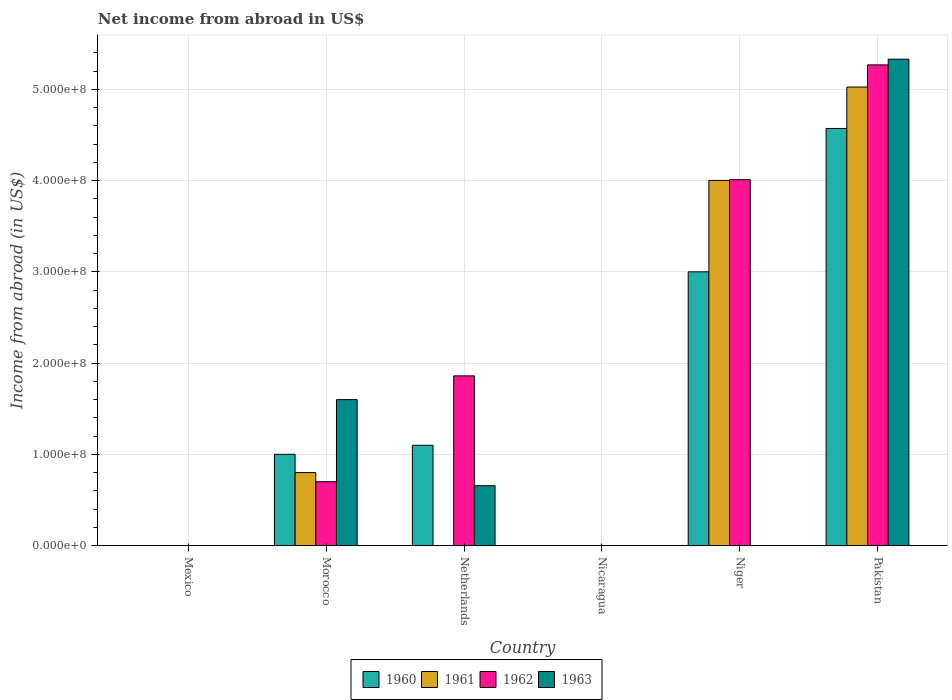How many different coloured bars are there?
Your answer should be very brief. 4. How many bars are there on the 1st tick from the right?
Your answer should be compact. 4. What is the label of the 5th group of bars from the left?
Offer a terse response. Niger. What is the net income from abroad in 1961 in Netherlands?
Offer a terse response. 0. Across all countries, what is the maximum net income from abroad in 1961?
Keep it short and to the point. 5.03e+08. Across all countries, what is the minimum net income from abroad in 1960?
Ensure brevity in your answer.  0. In which country was the net income from abroad in 1961 maximum?
Provide a short and direct response. Pakistan. What is the total net income from abroad in 1960 in the graph?
Ensure brevity in your answer.  9.67e+08. What is the difference between the net income from abroad in 1961 in Morocco and that in Niger?
Offer a terse response. -3.20e+08. What is the difference between the net income from abroad in 1960 in Pakistan and the net income from abroad in 1961 in Niger?
Offer a terse response. 5.70e+07. What is the average net income from abroad in 1961 per country?
Keep it short and to the point. 1.64e+08. What is the difference between the net income from abroad of/in 1961 and net income from abroad of/in 1960 in Morocco?
Give a very brief answer. -2.00e+07. In how many countries, is the net income from abroad in 1963 greater than 420000000 US$?
Ensure brevity in your answer.  1. What is the difference between the highest and the second highest net income from abroad in 1963?
Your answer should be very brief. 9.44e+07. What is the difference between the highest and the lowest net income from abroad in 1961?
Ensure brevity in your answer.  5.03e+08. Is it the case that in every country, the sum of the net income from abroad in 1960 and net income from abroad in 1963 is greater than the sum of net income from abroad in 1962 and net income from abroad in 1961?
Provide a succinct answer. No. Are all the bars in the graph horizontal?
Your answer should be compact. No. How many countries are there in the graph?
Your answer should be compact. 6. What is the difference between two consecutive major ticks on the Y-axis?
Make the answer very short. 1.00e+08. Are the values on the major ticks of Y-axis written in scientific E-notation?
Your answer should be compact. Yes. How many legend labels are there?
Your answer should be very brief. 4. What is the title of the graph?
Offer a terse response. Net income from abroad in US$. What is the label or title of the Y-axis?
Make the answer very short. Income from abroad (in US$). What is the Income from abroad (in US$) of 1961 in Mexico?
Provide a short and direct response. 0. What is the Income from abroad (in US$) of 1962 in Mexico?
Ensure brevity in your answer.  0. What is the Income from abroad (in US$) in 1963 in Mexico?
Offer a terse response. 0. What is the Income from abroad (in US$) of 1960 in Morocco?
Your answer should be very brief. 1.00e+08. What is the Income from abroad (in US$) in 1961 in Morocco?
Provide a succinct answer. 8.00e+07. What is the Income from abroad (in US$) of 1962 in Morocco?
Ensure brevity in your answer.  7.00e+07. What is the Income from abroad (in US$) in 1963 in Morocco?
Offer a very short reply. 1.60e+08. What is the Income from abroad (in US$) of 1960 in Netherlands?
Make the answer very short. 1.10e+08. What is the Income from abroad (in US$) of 1962 in Netherlands?
Provide a short and direct response. 1.86e+08. What is the Income from abroad (in US$) in 1963 in Netherlands?
Offer a very short reply. 6.56e+07. What is the Income from abroad (in US$) of 1960 in Nicaragua?
Ensure brevity in your answer.  0. What is the Income from abroad (in US$) in 1961 in Nicaragua?
Offer a terse response. 0. What is the Income from abroad (in US$) of 1962 in Nicaragua?
Your response must be concise. 0. What is the Income from abroad (in US$) of 1963 in Nicaragua?
Give a very brief answer. 0. What is the Income from abroad (in US$) of 1960 in Niger?
Ensure brevity in your answer.  3.00e+08. What is the Income from abroad (in US$) in 1961 in Niger?
Give a very brief answer. 4.00e+08. What is the Income from abroad (in US$) of 1962 in Niger?
Keep it short and to the point. 4.01e+08. What is the Income from abroad (in US$) in 1960 in Pakistan?
Provide a short and direct response. 4.57e+08. What is the Income from abroad (in US$) of 1961 in Pakistan?
Keep it short and to the point. 5.03e+08. What is the Income from abroad (in US$) in 1962 in Pakistan?
Provide a short and direct response. 5.27e+08. What is the Income from abroad (in US$) in 1963 in Pakistan?
Provide a succinct answer. 5.33e+08. Across all countries, what is the maximum Income from abroad (in US$) of 1960?
Provide a succinct answer. 4.57e+08. Across all countries, what is the maximum Income from abroad (in US$) in 1961?
Your answer should be very brief. 5.03e+08. Across all countries, what is the maximum Income from abroad (in US$) in 1962?
Keep it short and to the point. 5.27e+08. Across all countries, what is the maximum Income from abroad (in US$) in 1963?
Make the answer very short. 5.33e+08. Across all countries, what is the minimum Income from abroad (in US$) of 1960?
Offer a very short reply. 0. Across all countries, what is the minimum Income from abroad (in US$) of 1962?
Offer a very short reply. 0. What is the total Income from abroad (in US$) of 1960 in the graph?
Keep it short and to the point. 9.67e+08. What is the total Income from abroad (in US$) of 1961 in the graph?
Make the answer very short. 9.83e+08. What is the total Income from abroad (in US$) of 1962 in the graph?
Provide a short and direct response. 1.18e+09. What is the total Income from abroad (in US$) in 1963 in the graph?
Offer a very short reply. 7.59e+08. What is the difference between the Income from abroad (in US$) in 1960 in Morocco and that in Netherlands?
Your response must be concise. -9.95e+06. What is the difference between the Income from abroad (in US$) in 1962 in Morocco and that in Netherlands?
Keep it short and to the point. -1.16e+08. What is the difference between the Income from abroad (in US$) in 1963 in Morocco and that in Netherlands?
Give a very brief answer. 9.44e+07. What is the difference between the Income from abroad (in US$) of 1960 in Morocco and that in Niger?
Offer a terse response. -2.00e+08. What is the difference between the Income from abroad (in US$) of 1961 in Morocco and that in Niger?
Provide a succinct answer. -3.20e+08. What is the difference between the Income from abroad (in US$) of 1962 in Morocco and that in Niger?
Give a very brief answer. -3.31e+08. What is the difference between the Income from abroad (in US$) of 1960 in Morocco and that in Pakistan?
Provide a short and direct response. -3.57e+08. What is the difference between the Income from abroad (in US$) in 1961 in Morocco and that in Pakistan?
Give a very brief answer. -4.23e+08. What is the difference between the Income from abroad (in US$) in 1962 in Morocco and that in Pakistan?
Offer a terse response. -4.57e+08. What is the difference between the Income from abroad (in US$) in 1963 in Morocco and that in Pakistan?
Keep it short and to the point. -3.73e+08. What is the difference between the Income from abroad (in US$) in 1960 in Netherlands and that in Niger?
Ensure brevity in your answer.  -1.90e+08. What is the difference between the Income from abroad (in US$) in 1962 in Netherlands and that in Niger?
Ensure brevity in your answer.  -2.15e+08. What is the difference between the Income from abroad (in US$) in 1960 in Netherlands and that in Pakistan?
Offer a terse response. -3.47e+08. What is the difference between the Income from abroad (in US$) in 1962 in Netherlands and that in Pakistan?
Keep it short and to the point. -3.41e+08. What is the difference between the Income from abroad (in US$) in 1963 in Netherlands and that in Pakistan?
Your answer should be very brief. -4.68e+08. What is the difference between the Income from abroad (in US$) in 1960 in Niger and that in Pakistan?
Your answer should be compact. -1.57e+08. What is the difference between the Income from abroad (in US$) in 1961 in Niger and that in Pakistan?
Give a very brief answer. -1.02e+08. What is the difference between the Income from abroad (in US$) of 1962 in Niger and that in Pakistan?
Your answer should be compact. -1.26e+08. What is the difference between the Income from abroad (in US$) in 1960 in Morocco and the Income from abroad (in US$) in 1962 in Netherlands?
Make the answer very short. -8.60e+07. What is the difference between the Income from abroad (in US$) in 1960 in Morocco and the Income from abroad (in US$) in 1963 in Netherlands?
Provide a succinct answer. 3.44e+07. What is the difference between the Income from abroad (in US$) of 1961 in Morocco and the Income from abroad (in US$) of 1962 in Netherlands?
Give a very brief answer. -1.06e+08. What is the difference between the Income from abroad (in US$) in 1961 in Morocco and the Income from abroad (in US$) in 1963 in Netherlands?
Give a very brief answer. 1.44e+07. What is the difference between the Income from abroad (in US$) in 1962 in Morocco and the Income from abroad (in US$) in 1963 in Netherlands?
Offer a very short reply. 4.41e+06. What is the difference between the Income from abroad (in US$) of 1960 in Morocco and the Income from abroad (in US$) of 1961 in Niger?
Keep it short and to the point. -3.00e+08. What is the difference between the Income from abroad (in US$) in 1960 in Morocco and the Income from abroad (in US$) in 1962 in Niger?
Your response must be concise. -3.01e+08. What is the difference between the Income from abroad (in US$) in 1961 in Morocco and the Income from abroad (in US$) in 1962 in Niger?
Provide a short and direct response. -3.21e+08. What is the difference between the Income from abroad (in US$) of 1960 in Morocco and the Income from abroad (in US$) of 1961 in Pakistan?
Your answer should be very brief. -4.03e+08. What is the difference between the Income from abroad (in US$) in 1960 in Morocco and the Income from abroad (in US$) in 1962 in Pakistan?
Provide a succinct answer. -4.27e+08. What is the difference between the Income from abroad (in US$) in 1960 in Morocco and the Income from abroad (in US$) in 1963 in Pakistan?
Ensure brevity in your answer.  -4.33e+08. What is the difference between the Income from abroad (in US$) in 1961 in Morocco and the Income from abroad (in US$) in 1962 in Pakistan?
Your answer should be very brief. -4.47e+08. What is the difference between the Income from abroad (in US$) in 1961 in Morocco and the Income from abroad (in US$) in 1963 in Pakistan?
Your answer should be very brief. -4.53e+08. What is the difference between the Income from abroad (in US$) in 1962 in Morocco and the Income from abroad (in US$) in 1963 in Pakistan?
Keep it short and to the point. -4.63e+08. What is the difference between the Income from abroad (in US$) in 1960 in Netherlands and the Income from abroad (in US$) in 1961 in Niger?
Offer a very short reply. -2.90e+08. What is the difference between the Income from abroad (in US$) of 1960 in Netherlands and the Income from abroad (in US$) of 1962 in Niger?
Your answer should be very brief. -2.91e+08. What is the difference between the Income from abroad (in US$) of 1960 in Netherlands and the Income from abroad (in US$) of 1961 in Pakistan?
Offer a very short reply. -3.93e+08. What is the difference between the Income from abroad (in US$) in 1960 in Netherlands and the Income from abroad (in US$) in 1962 in Pakistan?
Provide a short and direct response. -4.17e+08. What is the difference between the Income from abroad (in US$) in 1960 in Netherlands and the Income from abroad (in US$) in 1963 in Pakistan?
Your response must be concise. -4.23e+08. What is the difference between the Income from abroad (in US$) in 1962 in Netherlands and the Income from abroad (in US$) in 1963 in Pakistan?
Keep it short and to the point. -3.47e+08. What is the difference between the Income from abroad (in US$) in 1960 in Niger and the Income from abroad (in US$) in 1961 in Pakistan?
Ensure brevity in your answer.  -2.03e+08. What is the difference between the Income from abroad (in US$) of 1960 in Niger and the Income from abroad (in US$) of 1962 in Pakistan?
Provide a short and direct response. -2.27e+08. What is the difference between the Income from abroad (in US$) of 1960 in Niger and the Income from abroad (in US$) of 1963 in Pakistan?
Your response must be concise. -2.33e+08. What is the difference between the Income from abroad (in US$) in 1961 in Niger and the Income from abroad (in US$) in 1962 in Pakistan?
Provide a succinct answer. -1.27e+08. What is the difference between the Income from abroad (in US$) of 1961 in Niger and the Income from abroad (in US$) of 1963 in Pakistan?
Keep it short and to the point. -1.33e+08. What is the difference between the Income from abroad (in US$) in 1962 in Niger and the Income from abroad (in US$) in 1963 in Pakistan?
Your answer should be very brief. -1.32e+08. What is the average Income from abroad (in US$) in 1960 per country?
Offer a terse response. 1.61e+08. What is the average Income from abroad (in US$) of 1961 per country?
Give a very brief answer. 1.64e+08. What is the average Income from abroad (in US$) in 1962 per country?
Provide a short and direct response. 1.97e+08. What is the average Income from abroad (in US$) of 1963 per country?
Your answer should be compact. 1.26e+08. What is the difference between the Income from abroad (in US$) of 1960 and Income from abroad (in US$) of 1961 in Morocco?
Keep it short and to the point. 2.00e+07. What is the difference between the Income from abroad (in US$) in 1960 and Income from abroad (in US$) in 1962 in Morocco?
Offer a very short reply. 3.00e+07. What is the difference between the Income from abroad (in US$) of 1960 and Income from abroad (in US$) of 1963 in Morocco?
Provide a succinct answer. -6.00e+07. What is the difference between the Income from abroad (in US$) of 1961 and Income from abroad (in US$) of 1962 in Morocco?
Your answer should be very brief. 1.00e+07. What is the difference between the Income from abroad (in US$) in 1961 and Income from abroad (in US$) in 1963 in Morocco?
Provide a short and direct response. -8.00e+07. What is the difference between the Income from abroad (in US$) of 1962 and Income from abroad (in US$) of 1963 in Morocco?
Offer a very short reply. -9.00e+07. What is the difference between the Income from abroad (in US$) of 1960 and Income from abroad (in US$) of 1962 in Netherlands?
Your response must be concise. -7.61e+07. What is the difference between the Income from abroad (in US$) of 1960 and Income from abroad (in US$) of 1963 in Netherlands?
Make the answer very short. 4.44e+07. What is the difference between the Income from abroad (in US$) of 1962 and Income from abroad (in US$) of 1963 in Netherlands?
Provide a succinct answer. 1.20e+08. What is the difference between the Income from abroad (in US$) in 1960 and Income from abroad (in US$) in 1961 in Niger?
Your answer should be compact. -1.00e+08. What is the difference between the Income from abroad (in US$) of 1960 and Income from abroad (in US$) of 1962 in Niger?
Your answer should be very brief. -1.01e+08. What is the difference between the Income from abroad (in US$) of 1961 and Income from abroad (in US$) of 1962 in Niger?
Offer a very short reply. -8.27e+05. What is the difference between the Income from abroad (in US$) in 1960 and Income from abroad (in US$) in 1961 in Pakistan?
Offer a terse response. -4.54e+07. What is the difference between the Income from abroad (in US$) in 1960 and Income from abroad (in US$) in 1962 in Pakistan?
Provide a short and direct response. -6.97e+07. What is the difference between the Income from abroad (in US$) in 1960 and Income from abroad (in US$) in 1963 in Pakistan?
Offer a very short reply. -7.59e+07. What is the difference between the Income from abroad (in US$) in 1961 and Income from abroad (in US$) in 1962 in Pakistan?
Provide a short and direct response. -2.43e+07. What is the difference between the Income from abroad (in US$) of 1961 and Income from abroad (in US$) of 1963 in Pakistan?
Offer a very short reply. -3.06e+07. What is the difference between the Income from abroad (in US$) of 1962 and Income from abroad (in US$) of 1963 in Pakistan?
Your response must be concise. -6.23e+06. What is the ratio of the Income from abroad (in US$) in 1960 in Morocco to that in Netherlands?
Your answer should be compact. 0.91. What is the ratio of the Income from abroad (in US$) in 1962 in Morocco to that in Netherlands?
Your response must be concise. 0.38. What is the ratio of the Income from abroad (in US$) in 1963 in Morocco to that in Netherlands?
Keep it short and to the point. 2.44. What is the ratio of the Income from abroad (in US$) of 1960 in Morocco to that in Niger?
Offer a very short reply. 0.33. What is the ratio of the Income from abroad (in US$) of 1961 in Morocco to that in Niger?
Ensure brevity in your answer.  0.2. What is the ratio of the Income from abroad (in US$) of 1962 in Morocco to that in Niger?
Your answer should be compact. 0.17. What is the ratio of the Income from abroad (in US$) of 1960 in Morocco to that in Pakistan?
Make the answer very short. 0.22. What is the ratio of the Income from abroad (in US$) in 1961 in Morocco to that in Pakistan?
Offer a very short reply. 0.16. What is the ratio of the Income from abroad (in US$) of 1962 in Morocco to that in Pakistan?
Make the answer very short. 0.13. What is the ratio of the Income from abroad (in US$) in 1963 in Morocco to that in Pakistan?
Keep it short and to the point. 0.3. What is the ratio of the Income from abroad (in US$) in 1960 in Netherlands to that in Niger?
Keep it short and to the point. 0.37. What is the ratio of the Income from abroad (in US$) of 1962 in Netherlands to that in Niger?
Give a very brief answer. 0.46. What is the ratio of the Income from abroad (in US$) of 1960 in Netherlands to that in Pakistan?
Offer a terse response. 0.24. What is the ratio of the Income from abroad (in US$) in 1962 in Netherlands to that in Pakistan?
Provide a short and direct response. 0.35. What is the ratio of the Income from abroad (in US$) of 1963 in Netherlands to that in Pakistan?
Keep it short and to the point. 0.12. What is the ratio of the Income from abroad (in US$) in 1960 in Niger to that in Pakistan?
Provide a succinct answer. 0.66. What is the ratio of the Income from abroad (in US$) of 1961 in Niger to that in Pakistan?
Make the answer very short. 0.8. What is the ratio of the Income from abroad (in US$) in 1962 in Niger to that in Pakistan?
Keep it short and to the point. 0.76. What is the difference between the highest and the second highest Income from abroad (in US$) of 1960?
Provide a short and direct response. 1.57e+08. What is the difference between the highest and the second highest Income from abroad (in US$) of 1961?
Your answer should be very brief. 1.02e+08. What is the difference between the highest and the second highest Income from abroad (in US$) of 1962?
Provide a succinct answer. 1.26e+08. What is the difference between the highest and the second highest Income from abroad (in US$) of 1963?
Keep it short and to the point. 3.73e+08. What is the difference between the highest and the lowest Income from abroad (in US$) in 1960?
Provide a succinct answer. 4.57e+08. What is the difference between the highest and the lowest Income from abroad (in US$) of 1961?
Offer a terse response. 5.03e+08. What is the difference between the highest and the lowest Income from abroad (in US$) in 1962?
Keep it short and to the point. 5.27e+08. What is the difference between the highest and the lowest Income from abroad (in US$) of 1963?
Keep it short and to the point. 5.33e+08. 